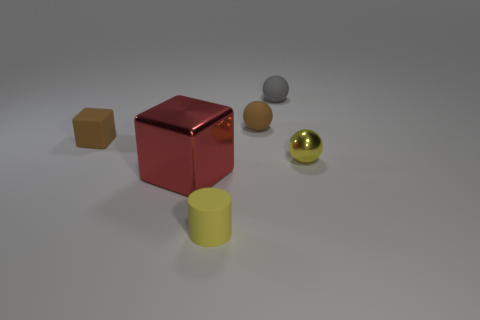How many objects are either rubber objects that are on the right side of the large red cube or small shiny balls?
Offer a very short reply. 4. There is a brown thing that is on the right side of the cube that is in front of the small brown cube; are there any tiny rubber balls right of it?
Your answer should be compact. Yes. What number of large yellow things are there?
Offer a very short reply. 0. How many objects are either yellow things behind the red cube or tiny balls that are in front of the rubber block?
Give a very brief answer. 1. Does the metallic object in front of the yellow metal sphere have the same size as the gray matte thing?
Provide a short and direct response. No. What material is the yellow sphere that is the same size as the gray sphere?
Your answer should be very brief. Metal. What material is the tiny yellow object that is the same shape as the tiny gray matte thing?
Provide a succinct answer. Metal. What number of other things are there of the same size as the gray thing?
Your answer should be very brief. 4. How many small cylinders have the same color as the small metal object?
Provide a succinct answer. 1. What is the shape of the big red object?
Your answer should be very brief. Cube. 